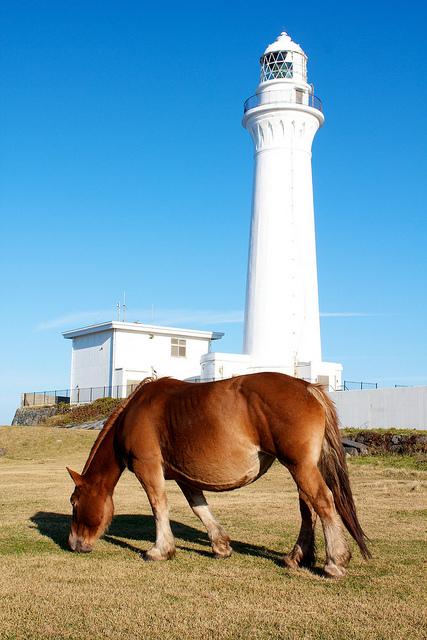Has this horse competed in the Kentucky Derby?
Be succinct. No. What is the horse doing?
Concise answer only. Grazing. Do you think this is a wild horse?
Give a very brief answer. No. 